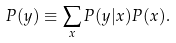Convert formula to latex. <formula><loc_0><loc_0><loc_500><loc_500>P ( y ) \equiv \sum _ { x } P ( y | x ) P ( x ) .</formula> 